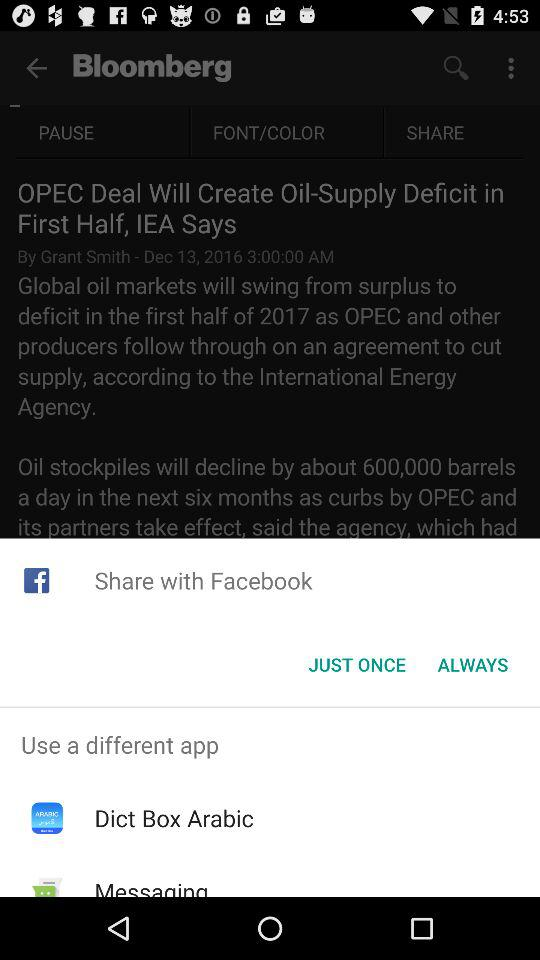What different applications can be used? The different applications that can be used are "Dict Box Arabic" and "Messaging". 